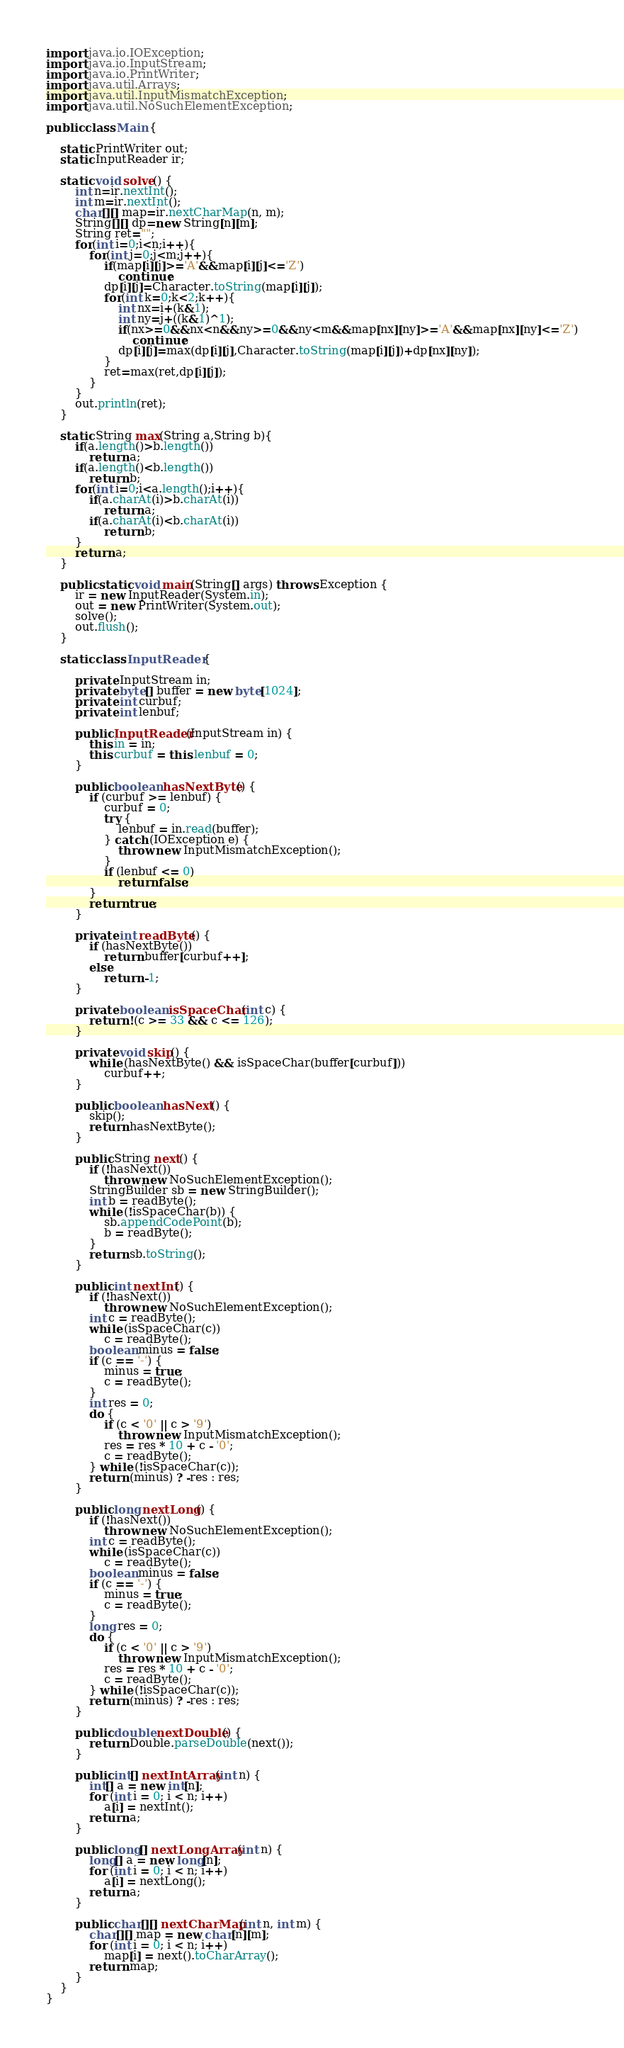<code> <loc_0><loc_0><loc_500><loc_500><_Java_>import java.io.IOException;
import java.io.InputStream;
import java.io.PrintWriter;
import java.util.Arrays;
import java.util.InputMismatchException;
import java.util.NoSuchElementException;

public class Main {

	static PrintWriter out;
	static InputReader ir;

	static void solve() {
		int n=ir.nextInt();
		int m=ir.nextInt();
		char[][] map=ir.nextCharMap(n, m);
		String[][] dp=new String[n][m];
		String ret="";
		for(int i=0;i<n;i++){
			for(int j=0;j<m;j++){
				if(map[i][j]>='A'&&map[i][j]<='Z')
					continue;
				dp[i][j]=Character.toString(map[i][j]);
				for(int k=0;k<2;k++){
					int nx=i+(k&1);
					int ny=j+((k&1)^1);
					if(nx>=0&&nx<n&&ny>=0&&ny<m&&map[nx][ny]>='A'&&map[nx][ny]<='Z')
						continue;
					dp[i][j]=max(dp[i][j],Character.toString(map[i][j])+dp[nx][ny]);
				}
				ret=max(ret,dp[i][j]);
			}
		}
		out.println(ret);
	}

	static String max(String a,String b){
		if(a.length()>b.length())
			return a;
		if(a.length()<b.length())
			return b;
		for(int i=0;i<a.length();i++){
			if(a.charAt(i)>b.charAt(i))
				return a;
			if(a.charAt(i)<b.charAt(i))
				return b;
		}
		return a;
	}
	
	public static void main(String[] args) throws Exception {
		ir = new InputReader(System.in);
		out = new PrintWriter(System.out);
		solve();
		out.flush();
	}

	static class InputReader {

		private InputStream in;
		private byte[] buffer = new byte[1024];
		private int curbuf;
		private int lenbuf;

		public InputReader(InputStream in) {
			this.in = in;
			this.curbuf = this.lenbuf = 0;
		}

		public boolean hasNextByte() {
			if (curbuf >= lenbuf) {
				curbuf = 0;
				try {
					lenbuf = in.read(buffer);
				} catch (IOException e) {
					throw new InputMismatchException();
				}
				if (lenbuf <= 0)
					return false;
			}
			return true;
		}

		private int readByte() {
			if (hasNextByte())
				return buffer[curbuf++];
			else
				return -1;
		}

		private boolean isSpaceChar(int c) {
			return !(c >= 33 && c <= 126);
		}

		private void skip() {
			while (hasNextByte() && isSpaceChar(buffer[curbuf]))
				curbuf++;
		}

		public boolean hasNext() {
			skip();
			return hasNextByte();
		}

		public String next() {
			if (!hasNext())
				throw new NoSuchElementException();
			StringBuilder sb = new StringBuilder();
			int b = readByte();
			while (!isSpaceChar(b)) {
				sb.appendCodePoint(b);
				b = readByte();
			}
			return sb.toString();
		}

		public int nextInt() {
			if (!hasNext())
				throw new NoSuchElementException();
			int c = readByte();
			while (isSpaceChar(c))
				c = readByte();
			boolean minus = false;
			if (c == '-') {
				minus = true;
				c = readByte();
			}
			int res = 0;
			do {
				if (c < '0' || c > '9')
					throw new InputMismatchException();
				res = res * 10 + c - '0';
				c = readByte();
			} while (!isSpaceChar(c));
			return (minus) ? -res : res;
		}

		public long nextLong() {
			if (!hasNext())
				throw new NoSuchElementException();
			int c = readByte();
			while (isSpaceChar(c))
				c = readByte();
			boolean minus = false;
			if (c == '-') {
				minus = true;
				c = readByte();
			}
			long res = 0;
			do {
				if (c < '0' || c > '9')
					throw new InputMismatchException();
				res = res * 10 + c - '0';
				c = readByte();
			} while (!isSpaceChar(c));
			return (minus) ? -res : res;
		}

		public double nextDouble() {
			return Double.parseDouble(next());
		}

		public int[] nextIntArray(int n) {
			int[] a = new int[n];
			for (int i = 0; i < n; i++)
				a[i] = nextInt();
			return a;
		}

		public long[] nextLongArray(int n) {
			long[] a = new long[n];
			for (int i = 0; i < n; i++)
				a[i] = nextLong();
			return a;
		}

		public char[][] nextCharMap(int n, int m) {
			char[][] map = new char[n][m];
			for (int i = 0; i < n; i++)
				map[i] = next().toCharArray();
			return map;
		}
	}
}

</code> 